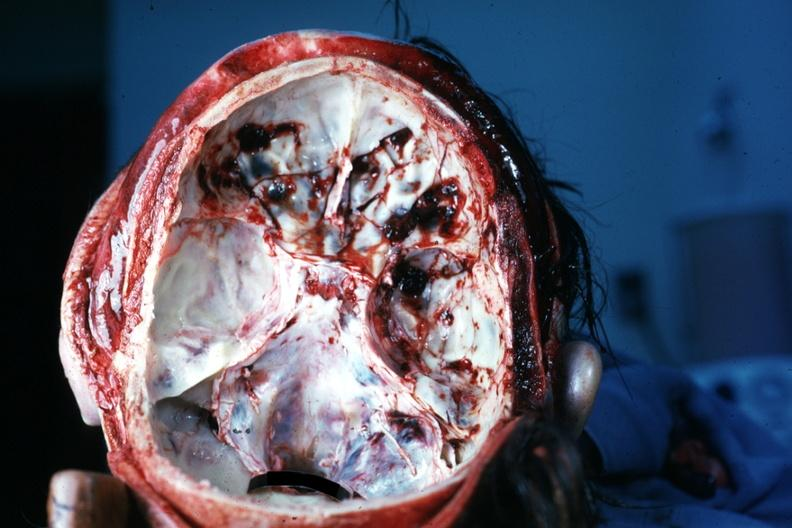does this image show multiple fractures very good?
Answer the question using a single word or phrase. Yes 